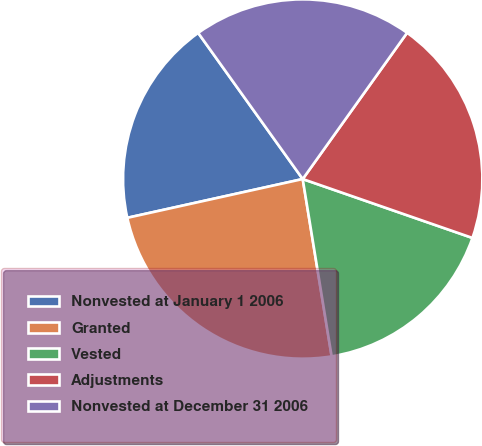Convert chart. <chart><loc_0><loc_0><loc_500><loc_500><pie_chart><fcel>Nonvested at January 1 2006<fcel>Granted<fcel>Vested<fcel>Adjustments<fcel>Nonvested at December 31 2006<nl><fcel>18.58%<fcel>24.11%<fcel>17.11%<fcel>20.45%<fcel>19.75%<nl></chart> 